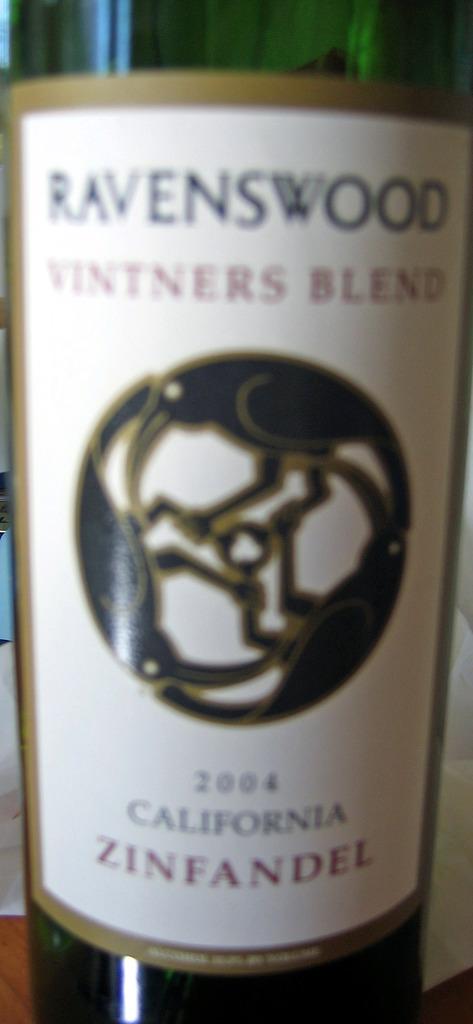What state was this beverage bottled?
Make the answer very short. California. What type of wine is shown?
Offer a terse response. Zinfandel. 